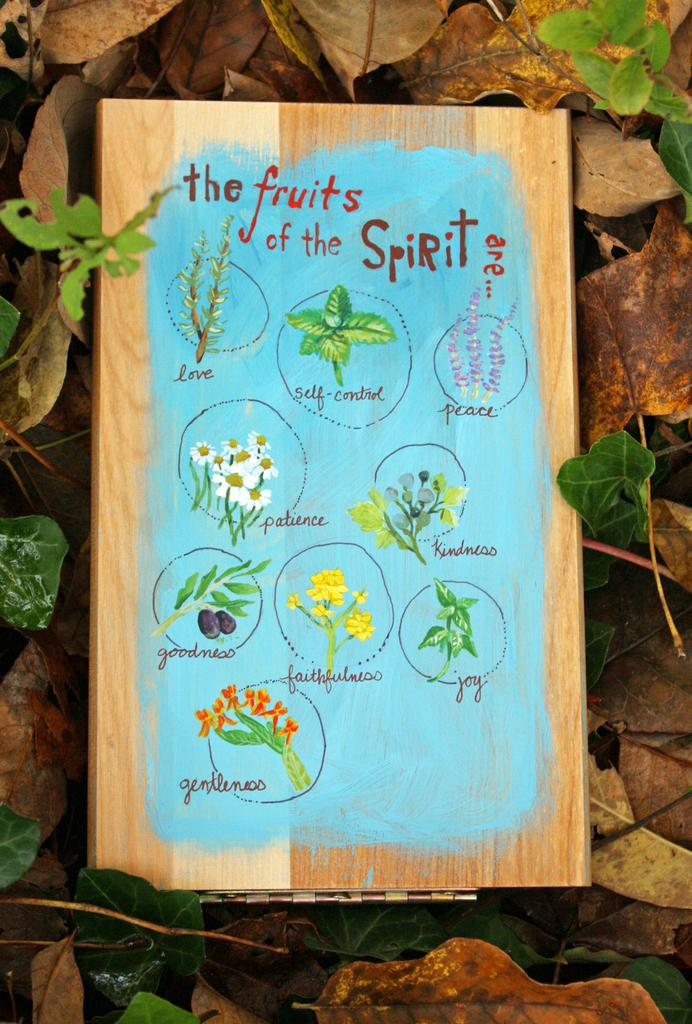What type of natural elements can be seen in the image? There are leaves in the image. What is the board with text used for in the image? The board with text is used to display a message or information. What is depicted on the board in the image? There is a painting on the board in the image. What type of account is being managed by the representative in the image? There is no representative or account present in the image. What does the image smell like? The image does not have a smell, as it is a visual representation. 